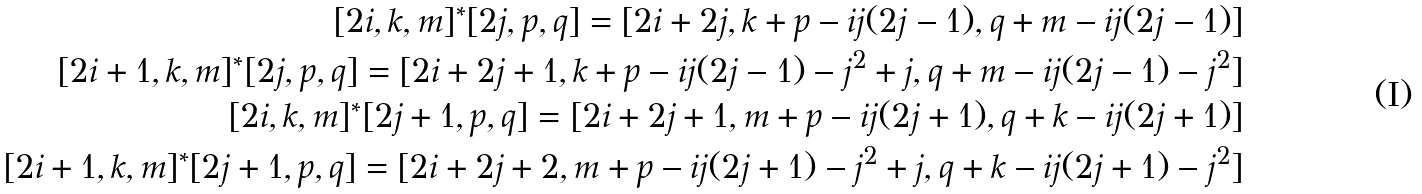Convert formula to latex. <formula><loc_0><loc_0><loc_500><loc_500>[ 2 i , k , m ] ^ { * } [ 2 j , p , q ] = [ 2 i + 2 j , k + p - i j ( 2 j - 1 ) , q + m - i j ( 2 j - 1 ) ] \\ [ 2 i + 1 , k , m ] ^ { * } [ 2 j , p , q ] = [ 2 i + 2 j + 1 , k + p - i j ( 2 j - 1 ) - j ^ { 2 } + j , q + m - i j ( 2 j - 1 ) - j ^ { 2 } ] \\ [ 2 i , k , m ] ^ { * } [ 2 j + 1 , p , q ] = [ 2 i + 2 j + 1 , m + p - i j ( 2 j + 1 ) , q + k - i j ( 2 j + 1 ) ] \\ [ 2 i + 1 , k , m ] ^ { * } [ 2 j + 1 , p , q ] = [ 2 i + 2 j + 2 , m + p - i j ( 2 j + 1 ) - j ^ { 2 } + j , q + k - i j ( 2 j + 1 ) - j ^ { 2 } ]</formula> 